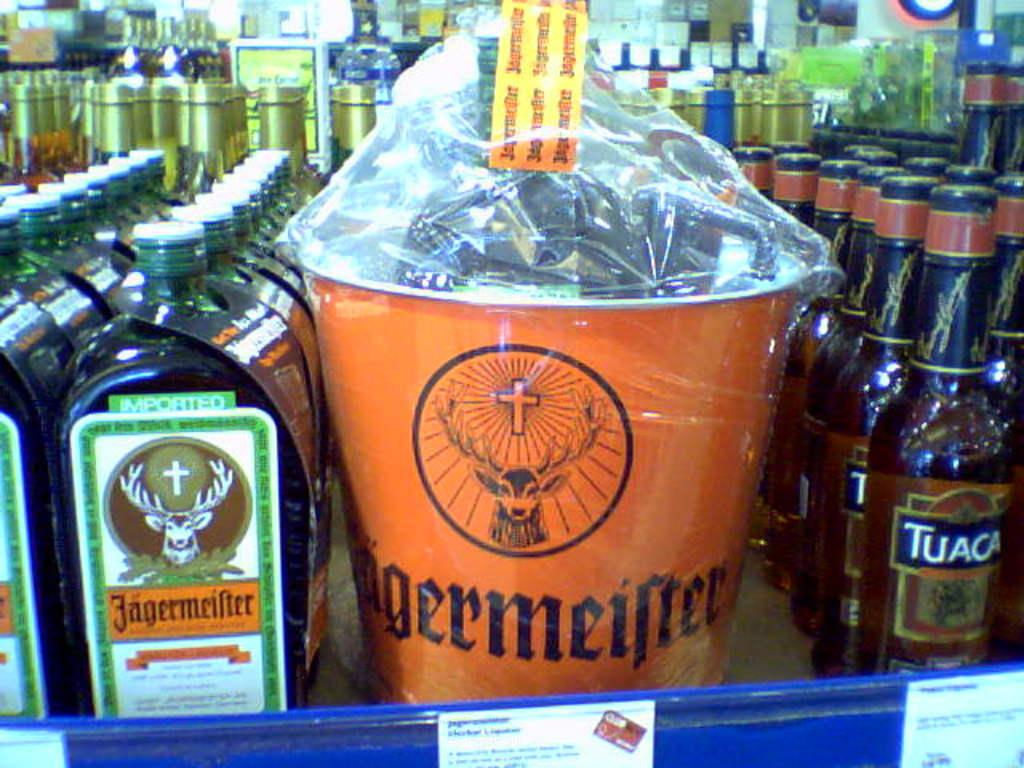<image>
Write a terse but informative summary of the picture. Bottles are labelled Tuaca are lined up in a row near other products. 